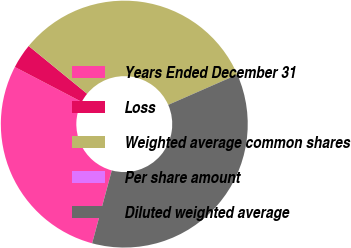Convert chart. <chart><loc_0><loc_0><loc_500><loc_500><pie_chart><fcel>Years Ended December 31<fcel>Loss<fcel>Weighted average common shares<fcel>Per share amount<fcel>Diluted weighted average<nl><fcel>28.46%<fcel>3.25%<fcel>32.52%<fcel>0.0%<fcel>35.77%<nl></chart> 